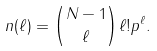<formula> <loc_0><loc_0><loc_500><loc_500>n ( \ell ) = \binom { N - 1 } { \ell } \ell ! p ^ { \ell } .</formula> 